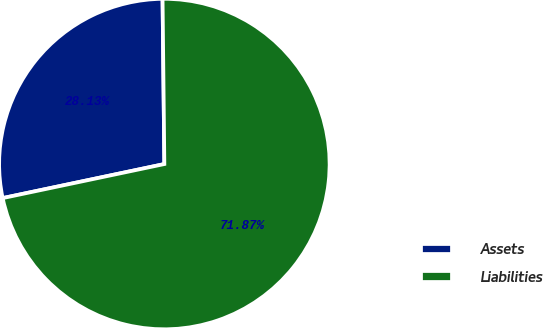Convert chart to OTSL. <chart><loc_0><loc_0><loc_500><loc_500><pie_chart><fcel>Assets<fcel>Liabilities<nl><fcel>28.13%<fcel>71.87%<nl></chart> 